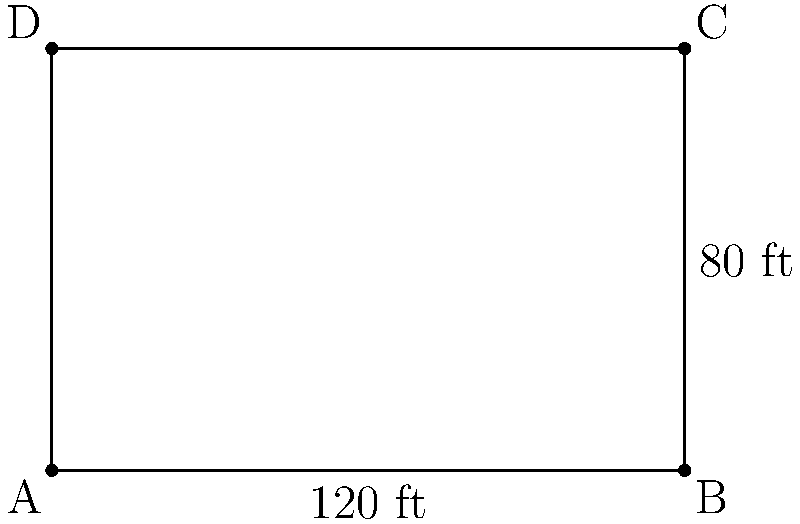Your insurance company is planning to install a fence around a rectangular parking lot for company vehicles. The lot measures 120 feet in length and 80 feet in width. If the cost of fencing is $45 per linear foot, what would be the total cost to fence the entire perimeter of the parking lot? To solve this problem, we'll follow these steps:

1. Calculate the perimeter of the rectangular parking lot:
   - Perimeter of a rectangle = 2 × (length + width)
   - Perimeter = 2 × (120 ft + 80 ft)
   - Perimeter = 2 × 200 ft = 400 ft

2. Calculate the cost of fencing:
   - Cost per linear foot = $45
   - Total cost = Perimeter × Cost per linear foot
   - Total cost = 400 ft × $45/ft = $18,000

Therefore, the total cost to fence the entire perimeter of the parking lot would be $18,000.
Answer: $18,000 